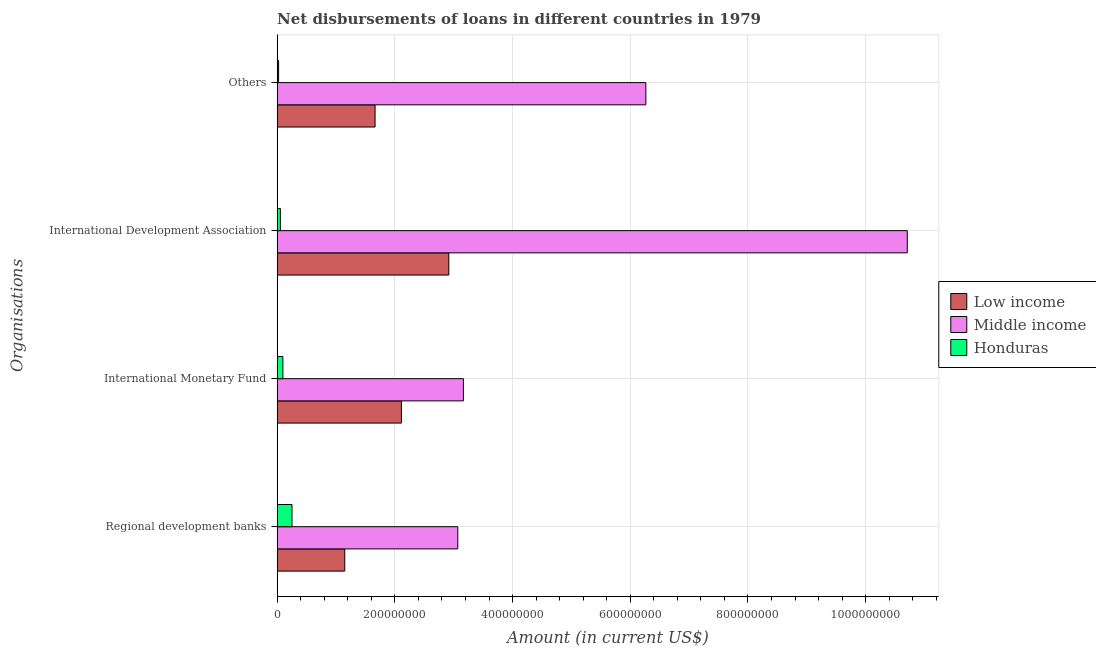How many different coloured bars are there?
Give a very brief answer. 3. How many groups of bars are there?
Offer a very short reply. 4. Are the number of bars on each tick of the Y-axis equal?
Make the answer very short. Yes. What is the label of the 4th group of bars from the top?
Offer a terse response. Regional development banks. What is the amount of loan disimbursed by international monetary fund in Middle income?
Offer a very short reply. 3.17e+08. Across all countries, what is the maximum amount of loan disimbursed by other organisations?
Provide a short and direct response. 6.26e+08. Across all countries, what is the minimum amount of loan disimbursed by other organisations?
Give a very brief answer. 2.52e+06. In which country was the amount of loan disimbursed by regional development banks minimum?
Your answer should be compact. Honduras. What is the total amount of loan disimbursed by international development association in the graph?
Your answer should be very brief. 1.37e+09. What is the difference between the amount of loan disimbursed by international monetary fund in Honduras and that in Low income?
Give a very brief answer. -2.01e+08. What is the difference between the amount of loan disimbursed by international monetary fund in Low income and the amount of loan disimbursed by regional development banks in Honduras?
Offer a very short reply. 1.86e+08. What is the average amount of loan disimbursed by regional development banks per country?
Offer a very short reply. 1.49e+08. What is the difference between the amount of loan disimbursed by other organisations and amount of loan disimbursed by international development association in Honduras?
Keep it short and to the point. -3.00e+06. What is the ratio of the amount of loan disimbursed by international development association in Low income to that in Middle income?
Make the answer very short. 0.27. What is the difference between the highest and the second highest amount of loan disimbursed by international monetary fund?
Give a very brief answer. 1.05e+08. What is the difference between the highest and the lowest amount of loan disimbursed by other organisations?
Your response must be concise. 6.24e+08. In how many countries, is the amount of loan disimbursed by international development association greater than the average amount of loan disimbursed by international development association taken over all countries?
Give a very brief answer. 1. Is the sum of the amount of loan disimbursed by international monetary fund in Honduras and Low income greater than the maximum amount of loan disimbursed by regional development banks across all countries?
Keep it short and to the point. No. Is it the case that in every country, the sum of the amount of loan disimbursed by regional development banks and amount of loan disimbursed by other organisations is greater than the sum of amount of loan disimbursed by international development association and amount of loan disimbursed by international monetary fund?
Provide a succinct answer. No. What does the 1st bar from the bottom in Regional development banks represents?
Your answer should be very brief. Low income. Is it the case that in every country, the sum of the amount of loan disimbursed by regional development banks and amount of loan disimbursed by international monetary fund is greater than the amount of loan disimbursed by international development association?
Provide a short and direct response. No. How many bars are there?
Make the answer very short. 12. Are all the bars in the graph horizontal?
Ensure brevity in your answer.  Yes. How many countries are there in the graph?
Provide a succinct answer. 3. What is the difference between two consecutive major ticks on the X-axis?
Offer a terse response. 2.00e+08. Does the graph contain any zero values?
Offer a very short reply. No. Does the graph contain grids?
Give a very brief answer. Yes. Where does the legend appear in the graph?
Offer a very short reply. Center right. How are the legend labels stacked?
Your answer should be compact. Vertical. What is the title of the graph?
Keep it short and to the point. Net disbursements of loans in different countries in 1979. Does "Mozambique" appear as one of the legend labels in the graph?
Offer a very short reply. No. What is the label or title of the X-axis?
Your answer should be very brief. Amount (in current US$). What is the label or title of the Y-axis?
Your response must be concise. Organisations. What is the Amount (in current US$) in Low income in Regional development banks?
Make the answer very short. 1.15e+08. What is the Amount (in current US$) of Middle income in Regional development banks?
Offer a very short reply. 3.07e+08. What is the Amount (in current US$) in Honduras in Regional development banks?
Your answer should be compact. 2.53e+07. What is the Amount (in current US$) in Low income in International Monetary Fund?
Provide a succinct answer. 2.11e+08. What is the Amount (in current US$) of Middle income in International Monetary Fund?
Your answer should be compact. 3.17e+08. What is the Amount (in current US$) of Honduras in International Monetary Fund?
Ensure brevity in your answer.  9.79e+06. What is the Amount (in current US$) in Low income in International Development Association?
Make the answer very short. 2.92e+08. What is the Amount (in current US$) of Middle income in International Development Association?
Make the answer very short. 1.07e+09. What is the Amount (in current US$) in Honduras in International Development Association?
Give a very brief answer. 5.51e+06. What is the Amount (in current US$) of Low income in Others?
Offer a terse response. 1.66e+08. What is the Amount (in current US$) in Middle income in Others?
Ensure brevity in your answer.  6.26e+08. What is the Amount (in current US$) of Honduras in Others?
Provide a succinct answer. 2.52e+06. Across all Organisations, what is the maximum Amount (in current US$) in Low income?
Your answer should be very brief. 2.92e+08. Across all Organisations, what is the maximum Amount (in current US$) of Middle income?
Your answer should be very brief. 1.07e+09. Across all Organisations, what is the maximum Amount (in current US$) of Honduras?
Offer a very short reply. 2.53e+07. Across all Organisations, what is the minimum Amount (in current US$) of Low income?
Offer a very short reply. 1.15e+08. Across all Organisations, what is the minimum Amount (in current US$) in Middle income?
Ensure brevity in your answer.  3.07e+08. Across all Organisations, what is the minimum Amount (in current US$) in Honduras?
Ensure brevity in your answer.  2.52e+06. What is the total Amount (in current US$) in Low income in the graph?
Your answer should be compact. 7.84e+08. What is the total Amount (in current US$) of Middle income in the graph?
Give a very brief answer. 2.32e+09. What is the total Amount (in current US$) of Honduras in the graph?
Provide a succinct answer. 4.31e+07. What is the difference between the Amount (in current US$) in Low income in Regional development banks and that in International Monetary Fund?
Keep it short and to the point. -9.62e+07. What is the difference between the Amount (in current US$) of Middle income in Regional development banks and that in International Monetary Fund?
Provide a short and direct response. -9.62e+06. What is the difference between the Amount (in current US$) of Honduras in Regional development banks and that in International Monetary Fund?
Provide a short and direct response. 1.55e+07. What is the difference between the Amount (in current US$) of Low income in Regional development banks and that in International Development Association?
Give a very brief answer. -1.77e+08. What is the difference between the Amount (in current US$) of Middle income in Regional development banks and that in International Development Association?
Provide a short and direct response. -7.64e+08. What is the difference between the Amount (in current US$) in Honduras in Regional development banks and that in International Development Association?
Offer a terse response. 1.98e+07. What is the difference between the Amount (in current US$) in Low income in Regional development banks and that in Others?
Make the answer very short. -5.15e+07. What is the difference between the Amount (in current US$) in Middle income in Regional development banks and that in Others?
Provide a short and direct response. -3.20e+08. What is the difference between the Amount (in current US$) of Honduras in Regional development banks and that in Others?
Make the answer very short. 2.28e+07. What is the difference between the Amount (in current US$) in Low income in International Monetary Fund and that in International Development Association?
Offer a very short reply. -8.06e+07. What is the difference between the Amount (in current US$) of Middle income in International Monetary Fund and that in International Development Association?
Your response must be concise. -7.54e+08. What is the difference between the Amount (in current US$) in Honduras in International Monetary Fund and that in International Development Association?
Provide a short and direct response. 4.27e+06. What is the difference between the Amount (in current US$) of Low income in International Monetary Fund and that in Others?
Make the answer very short. 4.47e+07. What is the difference between the Amount (in current US$) of Middle income in International Monetary Fund and that in Others?
Provide a short and direct response. -3.10e+08. What is the difference between the Amount (in current US$) in Honduras in International Monetary Fund and that in Others?
Give a very brief answer. 7.27e+06. What is the difference between the Amount (in current US$) of Low income in International Development Association and that in Others?
Provide a succinct answer. 1.25e+08. What is the difference between the Amount (in current US$) in Middle income in International Development Association and that in Others?
Your response must be concise. 4.44e+08. What is the difference between the Amount (in current US$) in Honduras in International Development Association and that in Others?
Provide a short and direct response. 3.00e+06. What is the difference between the Amount (in current US$) in Low income in Regional development banks and the Amount (in current US$) in Middle income in International Monetary Fund?
Ensure brevity in your answer.  -2.02e+08. What is the difference between the Amount (in current US$) of Low income in Regional development banks and the Amount (in current US$) of Honduras in International Monetary Fund?
Your answer should be very brief. 1.05e+08. What is the difference between the Amount (in current US$) of Middle income in Regional development banks and the Amount (in current US$) of Honduras in International Monetary Fund?
Your answer should be compact. 2.97e+08. What is the difference between the Amount (in current US$) of Low income in Regional development banks and the Amount (in current US$) of Middle income in International Development Association?
Your answer should be very brief. -9.56e+08. What is the difference between the Amount (in current US$) of Low income in Regional development banks and the Amount (in current US$) of Honduras in International Development Association?
Provide a succinct answer. 1.09e+08. What is the difference between the Amount (in current US$) of Middle income in Regional development banks and the Amount (in current US$) of Honduras in International Development Association?
Your response must be concise. 3.01e+08. What is the difference between the Amount (in current US$) in Low income in Regional development banks and the Amount (in current US$) in Middle income in Others?
Make the answer very short. -5.12e+08. What is the difference between the Amount (in current US$) in Low income in Regional development banks and the Amount (in current US$) in Honduras in Others?
Keep it short and to the point. 1.12e+08. What is the difference between the Amount (in current US$) of Middle income in Regional development banks and the Amount (in current US$) of Honduras in Others?
Ensure brevity in your answer.  3.04e+08. What is the difference between the Amount (in current US$) in Low income in International Monetary Fund and the Amount (in current US$) in Middle income in International Development Association?
Offer a very short reply. -8.59e+08. What is the difference between the Amount (in current US$) in Low income in International Monetary Fund and the Amount (in current US$) in Honduras in International Development Association?
Your response must be concise. 2.06e+08. What is the difference between the Amount (in current US$) of Middle income in International Monetary Fund and the Amount (in current US$) of Honduras in International Development Association?
Your answer should be compact. 3.11e+08. What is the difference between the Amount (in current US$) in Low income in International Monetary Fund and the Amount (in current US$) in Middle income in Others?
Offer a very short reply. -4.15e+08. What is the difference between the Amount (in current US$) of Low income in International Monetary Fund and the Amount (in current US$) of Honduras in Others?
Keep it short and to the point. 2.09e+08. What is the difference between the Amount (in current US$) of Middle income in International Monetary Fund and the Amount (in current US$) of Honduras in Others?
Your answer should be very brief. 3.14e+08. What is the difference between the Amount (in current US$) in Low income in International Development Association and the Amount (in current US$) in Middle income in Others?
Offer a terse response. -3.35e+08. What is the difference between the Amount (in current US$) in Low income in International Development Association and the Amount (in current US$) in Honduras in Others?
Offer a terse response. 2.89e+08. What is the difference between the Amount (in current US$) in Middle income in International Development Association and the Amount (in current US$) in Honduras in Others?
Ensure brevity in your answer.  1.07e+09. What is the average Amount (in current US$) in Low income per Organisations?
Provide a short and direct response. 1.96e+08. What is the average Amount (in current US$) of Middle income per Organisations?
Offer a terse response. 5.80e+08. What is the average Amount (in current US$) of Honduras per Organisations?
Make the answer very short. 1.08e+07. What is the difference between the Amount (in current US$) of Low income and Amount (in current US$) of Middle income in Regional development banks?
Provide a short and direct response. -1.92e+08. What is the difference between the Amount (in current US$) of Low income and Amount (in current US$) of Honduras in Regional development banks?
Provide a succinct answer. 8.96e+07. What is the difference between the Amount (in current US$) of Middle income and Amount (in current US$) of Honduras in Regional development banks?
Provide a short and direct response. 2.82e+08. What is the difference between the Amount (in current US$) in Low income and Amount (in current US$) in Middle income in International Monetary Fund?
Provide a short and direct response. -1.05e+08. What is the difference between the Amount (in current US$) in Low income and Amount (in current US$) in Honduras in International Monetary Fund?
Your response must be concise. 2.01e+08. What is the difference between the Amount (in current US$) in Middle income and Amount (in current US$) in Honduras in International Monetary Fund?
Offer a terse response. 3.07e+08. What is the difference between the Amount (in current US$) of Low income and Amount (in current US$) of Middle income in International Development Association?
Your answer should be compact. -7.79e+08. What is the difference between the Amount (in current US$) of Low income and Amount (in current US$) of Honduras in International Development Association?
Offer a terse response. 2.86e+08. What is the difference between the Amount (in current US$) in Middle income and Amount (in current US$) in Honduras in International Development Association?
Your answer should be very brief. 1.07e+09. What is the difference between the Amount (in current US$) of Low income and Amount (in current US$) of Middle income in Others?
Offer a terse response. -4.60e+08. What is the difference between the Amount (in current US$) of Low income and Amount (in current US$) of Honduras in Others?
Provide a short and direct response. 1.64e+08. What is the difference between the Amount (in current US$) of Middle income and Amount (in current US$) of Honduras in Others?
Offer a very short reply. 6.24e+08. What is the ratio of the Amount (in current US$) of Low income in Regional development banks to that in International Monetary Fund?
Your answer should be compact. 0.54. What is the ratio of the Amount (in current US$) of Middle income in Regional development banks to that in International Monetary Fund?
Your answer should be compact. 0.97. What is the ratio of the Amount (in current US$) in Honduras in Regional development banks to that in International Monetary Fund?
Offer a very short reply. 2.59. What is the ratio of the Amount (in current US$) of Low income in Regional development banks to that in International Development Association?
Offer a very short reply. 0.39. What is the ratio of the Amount (in current US$) in Middle income in Regional development banks to that in International Development Association?
Your answer should be very brief. 0.29. What is the ratio of the Amount (in current US$) of Honduras in Regional development banks to that in International Development Association?
Provide a short and direct response. 4.59. What is the ratio of the Amount (in current US$) in Low income in Regional development banks to that in Others?
Offer a very short reply. 0.69. What is the ratio of the Amount (in current US$) of Middle income in Regional development banks to that in Others?
Offer a terse response. 0.49. What is the ratio of the Amount (in current US$) of Honduras in Regional development banks to that in Others?
Give a very brief answer. 10.05. What is the ratio of the Amount (in current US$) of Low income in International Monetary Fund to that in International Development Association?
Provide a short and direct response. 0.72. What is the ratio of the Amount (in current US$) in Middle income in International Monetary Fund to that in International Development Association?
Make the answer very short. 0.3. What is the ratio of the Amount (in current US$) in Honduras in International Monetary Fund to that in International Development Association?
Make the answer very short. 1.77. What is the ratio of the Amount (in current US$) in Low income in International Monetary Fund to that in Others?
Provide a short and direct response. 1.27. What is the ratio of the Amount (in current US$) of Middle income in International Monetary Fund to that in Others?
Provide a succinct answer. 0.51. What is the ratio of the Amount (in current US$) of Honduras in International Monetary Fund to that in Others?
Ensure brevity in your answer.  3.89. What is the ratio of the Amount (in current US$) in Low income in International Development Association to that in Others?
Provide a short and direct response. 1.75. What is the ratio of the Amount (in current US$) in Middle income in International Development Association to that in Others?
Offer a terse response. 1.71. What is the ratio of the Amount (in current US$) of Honduras in International Development Association to that in Others?
Offer a terse response. 2.19. What is the difference between the highest and the second highest Amount (in current US$) in Low income?
Provide a succinct answer. 8.06e+07. What is the difference between the highest and the second highest Amount (in current US$) in Middle income?
Provide a succinct answer. 4.44e+08. What is the difference between the highest and the second highest Amount (in current US$) of Honduras?
Your answer should be compact. 1.55e+07. What is the difference between the highest and the lowest Amount (in current US$) of Low income?
Your answer should be very brief. 1.77e+08. What is the difference between the highest and the lowest Amount (in current US$) in Middle income?
Ensure brevity in your answer.  7.64e+08. What is the difference between the highest and the lowest Amount (in current US$) in Honduras?
Your response must be concise. 2.28e+07. 